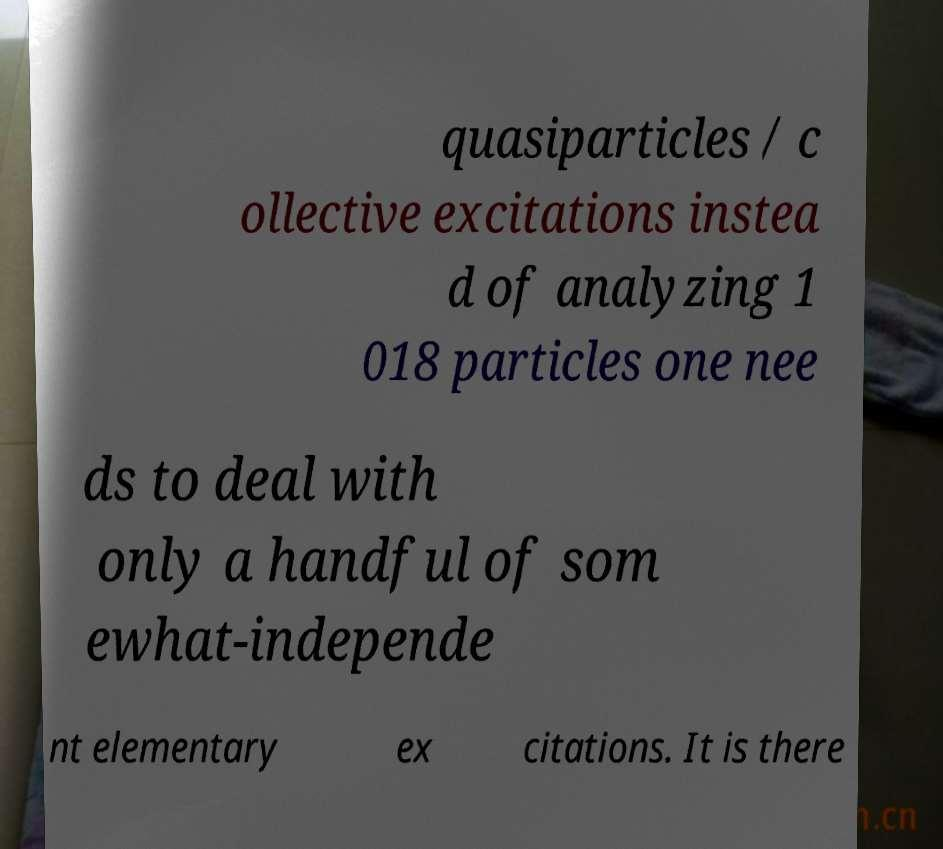There's text embedded in this image that I need extracted. Can you transcribe it verbatim? quasiparticles / c ollective excitations instea d of analyzing 1 018 particles one nee ds to deal with only a handful of som ewhat-independe nt elementary ex citations. It is there 